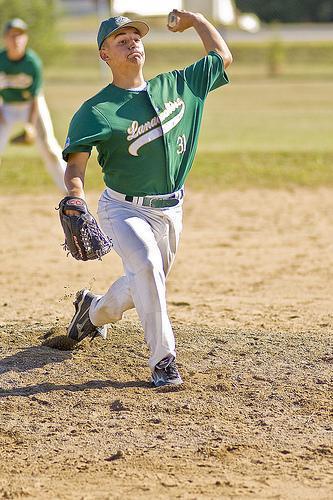How many players are in the photo?
Give a very brief answer. 2. 